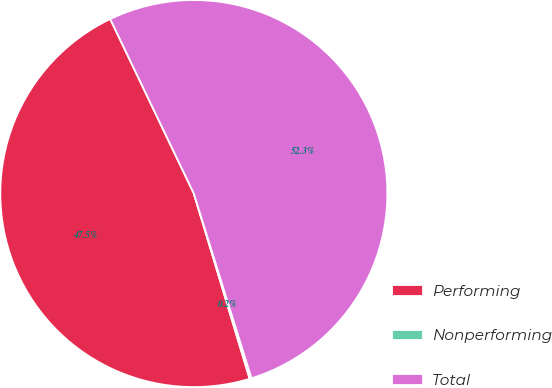Convert chart. <chart><loc_0><loc_0><loc_500><loc_500><pie_chart><fcel>Performing<fcel>Nonperforming<fcel>Total<nl><fcel>47.54%<fcel>0.16%<fcel>52.29%<nl></chart> 